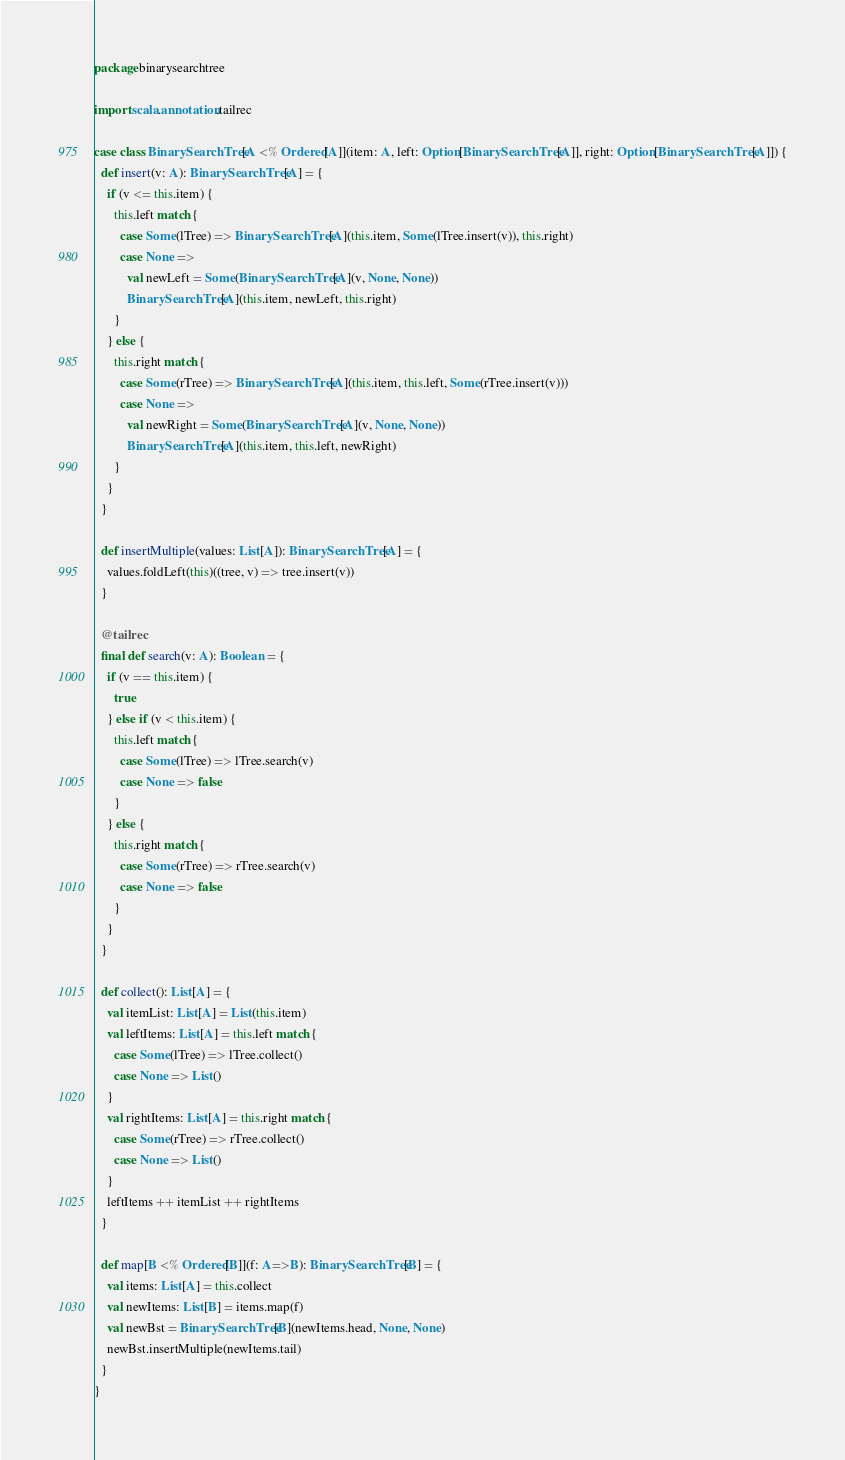Convert code to text. <code><loc_0><loc_0><loc_500><loc_500><_Scala_>package binarysearchtree

import scala.annotation.tailrec

case class BinarySearchTree[A <% Ordered[A]](item: A, left: Option[BinarySearchTree[A]], right: Option[BinarySearchTree[A]]) {
  def insert(v: A): BinarySearchTree[A] = {
    if (v <= this.item) {
      this.left match {
        case Some(lTree) => BinarySearchTree[A](this.item, Some(lTree.insert(v)), this.right)
        case None =>
          val newLeft = Some(BinarySearchTree[A](v, None, None))
          BinarySearchTree[A](this.item, newLeft, this.right)
      }
    } else {
      this.right match {
        case Some(rTree) => BinarySearchTree[A](this.item, this.left, Some(rTree.insert(v)))
        case None =>
          val newRight = Some(BinarySearchTree[A](v, None, None))
          BinarySearchTree[A](this.item, this.left, newRight)
      }
    }
  }

  def insertMultiple(values: List[A]): BinarySearchTree[A] = {
    values.foldLeft(this)((tree, v) => tree.insert(v))
  }

  @tailrec
  final def search(v: A): Boolean = {
    if (v == this.item) {
      true
    } else if (v < this.item) {
      this.left match {
        case Some(lTree) => lTree.search(v)
        case None => false
      }
    } else {
      this.right match {
        case Some(rTree) => rTree.search(v)
        case None => false
      }
    }
  }

  def collect(): List[A] = {
    val itemList: List[A] = List(this.item)
    val leftItems: List[A] = this.left match {
      case Some(lTree) => lTree.collect()
      case None => List()
    }
    val rightItems: List[A] = this.right match {
      case Some(rTree) => rTree.collect()
      case None => List()
    }
    leftItems ++ itemList ++ rightItems
  }

  def map[B <% Ordered[B]](f: A=>B): BinarySearchTree[B] = {
    val items: List[A] = this.collect
    val newItems: List[B] = items.map(f)
    val newBst = BinarySearchTree[B](newItems.head, None, None)
    newBst.insertMultiple(newItems.tail)
  }
}
</code> 